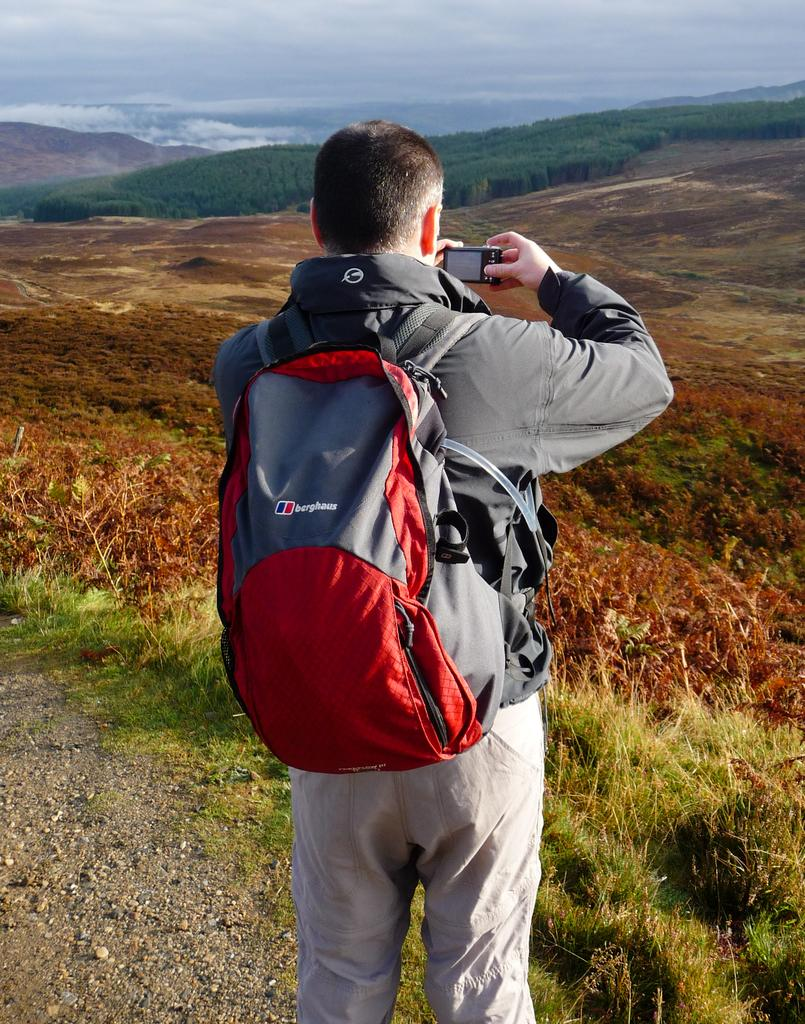<image>
Summarize the visual content of the image. A man with a berghaus backpack takes a picture 